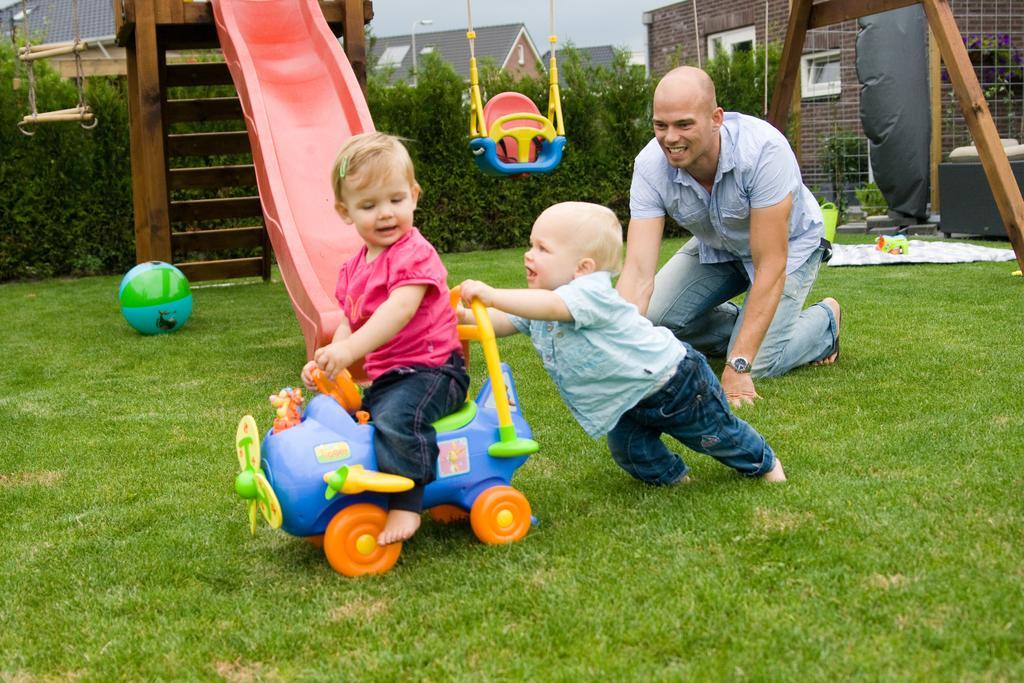Please provide a concise description of this image. There are two kids playing with a toy. Here is the man sitting on his knees. This looks like a swing hanging. I think this is a sliding board. These are the wooden stairs. This is a ball lying on the grass. I can see the bushes. These are the houses with the windows. This looks like a mat with the toys on it. 